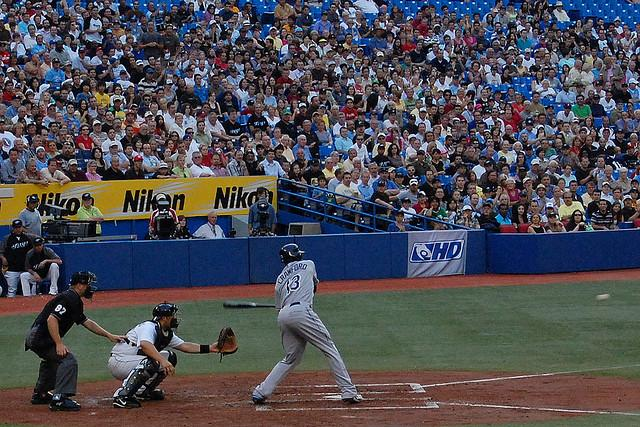The player swinging has the same dominant hand as what person?

Choices:
A) kris bryant
B) mike trout
C) fred mcgriff
D) manny ramirez fred mcgriff 